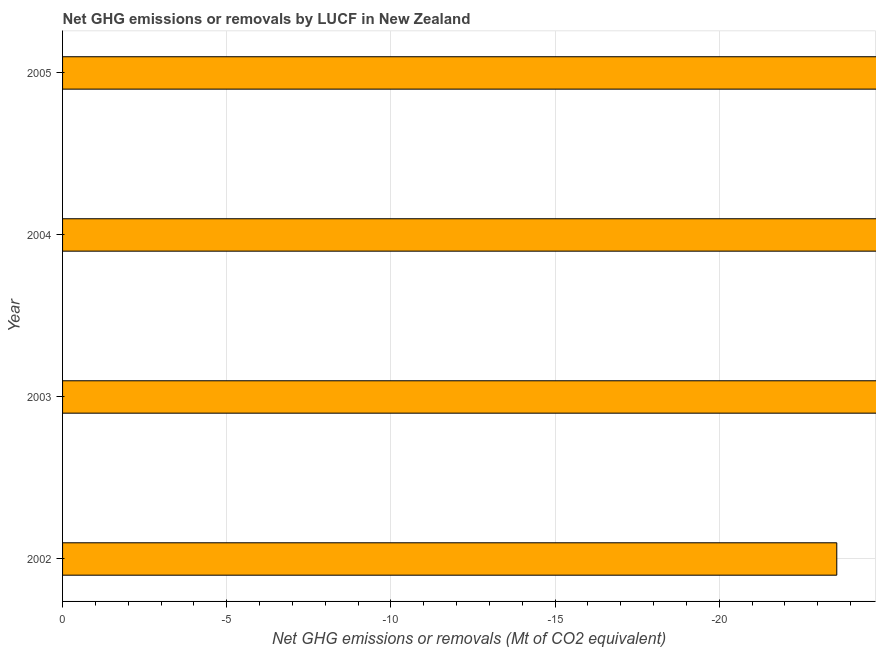Does the graph contain grids?
Keep it short and to the point. Yes. What is the title of the graph?
Keep it short and to the point. Net GHG emissions or removals by LUCF in New Zealand. What is the label or title of the X-axis?
Your answer should be very brief. Net GHG emissions or removals (Mt of CO2 equivalent). What is the label or title of the Y-axis?
Give a very brief answer. Year. What is the sum of the ghg net emissions or removals?
Offer a terse response. 0. What is the median ghg net emissions or removals?
Give a very brief answer. 0. In how many years, is the ghg net emissions or removals greater than the average ghg net emissions or removals taken over all years?
Keep it short and to the point. 0. Are all the bars in the graph horizontal?
Ensure brevity in your answer.  Yes. How many years are there in the graph?
Your answer should be compact. 4. What is the difference between two consecutive major ticks on the X-axis?
Offer a very short reply. 5. What is the Net GHG emissions or removals (Mt of CO2 equivalent) in 2003?
Provide a succinct answer. 0. What is the Net GHG emissions or removals (Mt of CO2 equivalent) of 2004?
Your response must be concise. 0. 